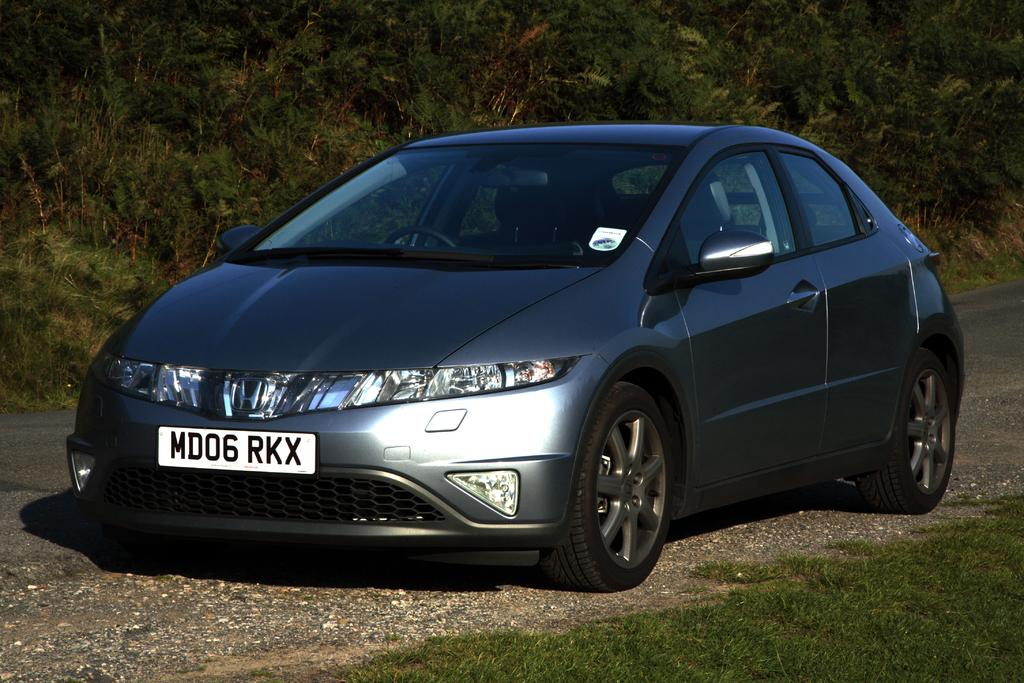What is the main subject of the image? The main subject of the image is a car. What type of terrain is visible at the bottom of the image? There is grass at the bottom of the image. What can be seen in the background of the image? There are trees visible in the background of the image. What color is the button on the car's dashboard in the image? There is no button mentioned in the provided facts, and no information about the car's dashboard is given. --- Facts: 1. There is a person sitting on a bench in the image. 2. The person is reading a book. 3. There is a tree behind the bench. 4. The sky is visible in the image. Absurd Topics: parrot, ocean, bicycle Conversation: What is the person in the image doing? The person is sitting on a bench and reading a book. What can be seen behind the bench in the image? There is a tree behind the bench. What is visible in the background of the image? The sky is visible in the image. Reasoning: Let's think step by step in order to produce the conversation. We start by identifying the main subject of the image, which is the person sitting on the bench. Then, we describe the person's activity, which is reading a book. Next, we mention the object behind the bench, which is a tree. Finally, we describe the background of the image, which includes the sky. Each question is designed to elicit a specific detail about the image that is known from the provided facts. Absurd Question/Answer: Can you see the ocean in the background of the image? There is no mention of an ocean in the provided facts, and the image does not show any water or beach. 